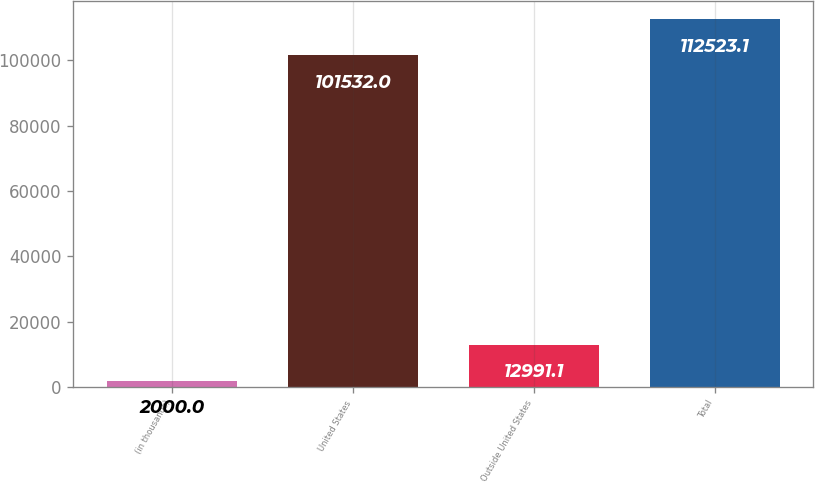Convert chart. <chart><loc_0><loc_0><loc_500><loc_500><bar_chart><fcel>(in thousands)<fcel>United States<fcel>Outside United States<fcel>Total<nl><fcel>2000<fcel>101532<fcel>12991.1<fcel>112523<nl></chart> 